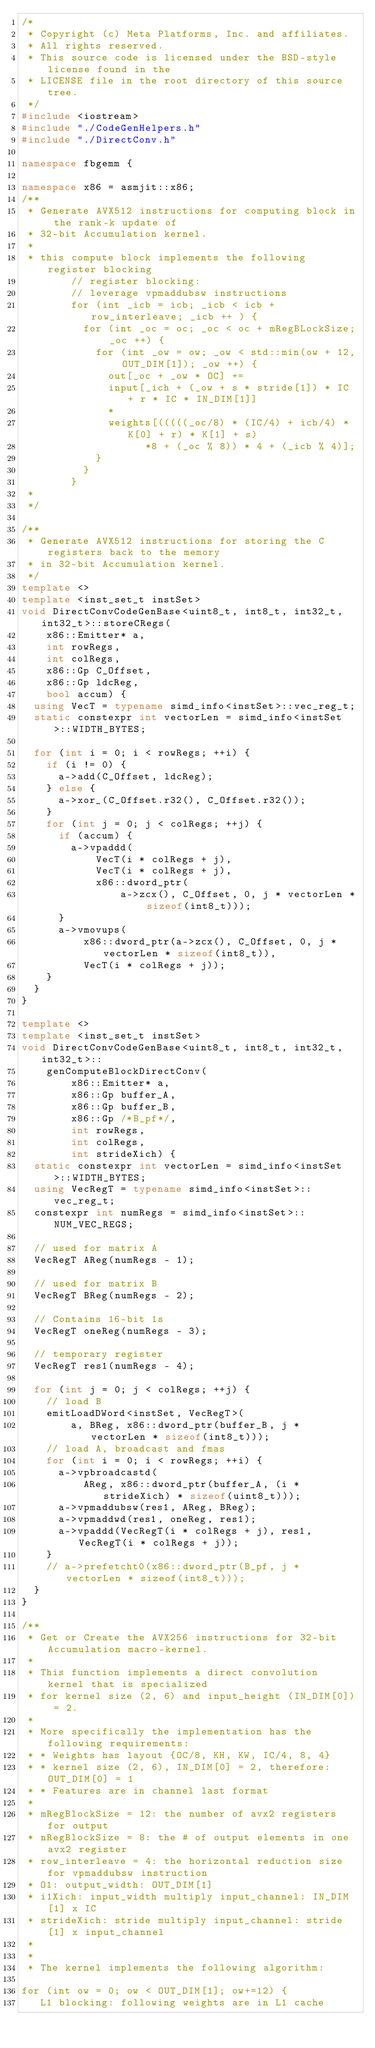Convert code to text. <code><loc_0><loc_0><loc_500><loc_500><_C++_>/*
 * Copyright (c) Meta Platforms, Inc. and affiliates.
 * All rights reserved.
 * This source code is licensed under the BSD-style license found in the
 * LICENSE file in the root directory of this source tree.
 */
#include <iostream>
#include "./CodeGenHelpers.h"
#include "./DirectConv.h"

namespace fbgemm {

namespace x86 = asmjit::x86;
/**
 * Generate AVX512 instructions for computing block in the rank-k update of
 * 32-bit Accumulation kernel.
 *
 * this compute block implements the following register blocking
        // register blocking:
        // leverage vpmaddubsw instructions
        for (int _icb = icb; _icb < icb + row_interleave; _icb ++ ) {
          for (int _oc = oc; _oc < oc + mRegBLockSize; _oc ++) {
            for (int _ow = ow; _ow < std::min(ow + 12, OUT_DIM[1]); _ow ++) {
              out[_oc + _ow * OC] +=
              input[_ich + (_ow + s * stride[1]) * IC + r * IC * IN_DIM[1]]
              *
              weights[(((((_oc/8) * (IC/4) + icb/4) * K[0] + r) * K[1] + s)
                    *8 + (_oc % 8)) * 4 + (_icb % 4)];
            }
          }
        }
 *
 */

/**
 * Generate AVX512 instructions for storing the C registers back to the memory
 * in 32-bit Accumulation kernel.
 */
template <>
template <inst_set_t instSet>
void DirectConvCodeGenBase<uint8_t, int8_t, int32_t, int32_t>::storeCRegs(
    x86::Emitter* a,
    int rowRegs,
    int colRegs,
    x86::Gp C_Offset,
    x86::Gp ldcReg,
    bool accum) {
  using VecT = typename simd_info<instSet>::vec_reg_t;
  static constexpr int vectorLen = simd_info<instSet>::WIDTH_BYTES;

  for (int i = 0; i < rowRegs; ++i) {
    if (i != 0) {
      a->add(C_Offset, ldcReg);
    } else {
      a->xor_(C_Offset.r32(), C_Offset.r32());
    }
    for (int j = 0; j < colRegs; ++j) {
      if (accum) {
        a->vpaddd(
            VecT(i * colRegs + j),
            VecT(i * colRegs + j),
            x86::dword_ptr(
                a->zcx(), C_Offset, 0, j * vectorLen * sizeof(int8_t)));
      }
      a->vmovups(
          x86::dword_ptr(a->zcx(), C_Offset, 0, j * vectorLen * sizeof(int8_t)),
          VecT(i * colRegs + j));
    }
  }
}

template <>
template <inst_set_t instSet>
void DirectConvCodeGenBase<uint8_t, int8_t, int32_t, int32_t>::
    genComputeBlockDirectConv(
        x86::Emitter* a,
        x86::Gp buffer_A,
        x86::Gp buffer_B,
        x86::Gp /*B_pf*/,
        int rowRegs,
        int colRegs,
        int strideXich) {
  static constexpr int vectorLen = simd_info<instSet>::WIDTH_BYTES;
  using VecRegT = typename simd_info<instSet>::vec_reg_t;
  constexpr int numRegs = simd_info<instSet>::NUM_VEC_REGS;

  // used for matrix A
  VecRegT AReg(numRegs - 1);

  // used for matrix B
  VecRegT BReg(numRegs - 2);

  // Contains 16-bit 1s
  VecRegT oneReg(numRegs - 3);

  // temporary register
  VecRegT res1(numRegs - 4);

  for (int j = 0; j < colRegs; ++j) {
    // load B
    emitLoadDWord<instSet, VecRegT>(
        a, BReg, x86::dword_ptr(buffer_B, j * vectorLen * sizeof(int8_t)));
    // load A, broadcast and fmas
    for (int i = 0; i < rowRegs; ++i) {
      a->vpbroadcastd(
          AReg, x86::dword_ptr(buffer_A, (i * strideXich) * sizeof(uint8_t)));
      a->vpmaddubsw(res1, AReg, BReg);
      a->vpmaddwd(res1, oneReg, res1);
      a->vpaddd(VecRegT(i * colRegs + j), res1, VecRegT(i * colRegs + j));
    }
    // a->prefetcht0(x86::dword_ptr(B_pf, j * vectorLen * sizeof(int8_t)));
  }
}

/**
 * Get or Create the AVX256 instructions for 32-bit Accumulation macro-kernel.
 *
 * This function implements a direct convolution kernel that is specialized
 * for kernel size (2, 6) and input_height (IN_DIM[0]) = 2.
 *
 * More specifically the implementation has the following requirements:
 * * Weights has layout {OC/8, KH, KW, IC/4, 8, 4}
 * * kernel size (2, 6), IN_DIM[0] = 2, therefore: OUT_DIM[0] = 1
 * * Features are in channel last format
 *
 * mRegBlockSize = 12: the number of avx2 registers for output
 * nRegBlockSize = 8: the # of output elements in one avx2 register
 * row_interleave = 4: the horizontal reduction size for vpmaddubsw instruction
 * O1: output_width: OUT_DIM[1]
 * i1Xich: input_width multiply input_channel: IN_DIM[1] x IC
 * strideXich: stride multiply input_channel: stride[1] x input_channel
 *
 *
 * The kernel implements the following algorithm:

for (int ow = 0; ow < OUT_DIM[1]; ow+=12) {
   L1 blocking: following weights are in L1 cache</code> 